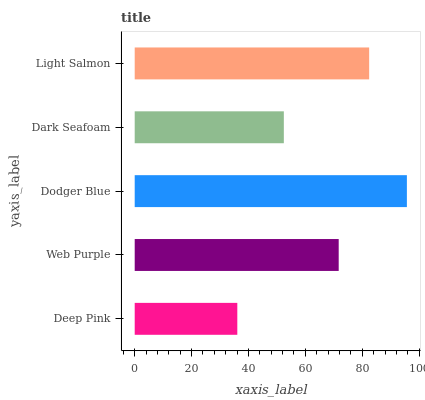Is Deep Pink the minimum?
Answer yes or no. Yes. Is Dodger Blue the maximum?
Answer yes or no. Yes. Is Web Purple the minimum?
Answer yes or no. No. Is Web Purple the maximum?
Answer yes or no. No. Is Web Purple greater than Deep Pink?
Answer yes or no. Yes. Is Deep Pink less than Web Purple?
Answer yes or no. Yes. Is Deep Pink greater than Web Purple?
Answer yes or no. No. Is Web Purple less than Deep Pink?
Answer yes or no. No. Is Web Purple the high median?
Answer yes or no. Yes. Is Web Purple the low median?
Answer yes or no. Yes. Is Dark Seafoam the high median?
Answer yes or no. No. Is Light Salmon the low median?
Answer yes or no. No. 